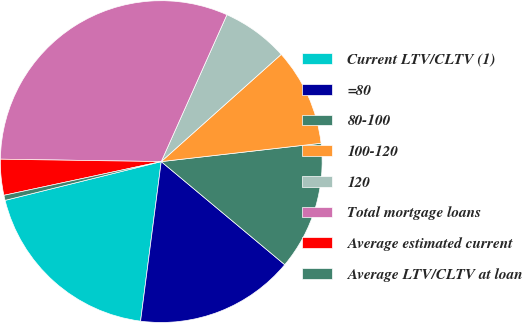<chart> <loc_0><loc_0><loc_500><loc_500><pie_chart><fcel>Current LTV/CLTV (1)<fcel>=80<fcel>80-100<fcel>100-120<fcel>120<fcel>Total mortgage loans<fcel>Average estimated current<fcel>Average LTV/CLTV at loan<nl><fcel>19.08%<fcel>15.98%<fcel>12.89%<fcel>9.79%<fcel>6.7%<fcel>31.46%<fcel>3.6%<fcel>0.51%<nl></chart> 